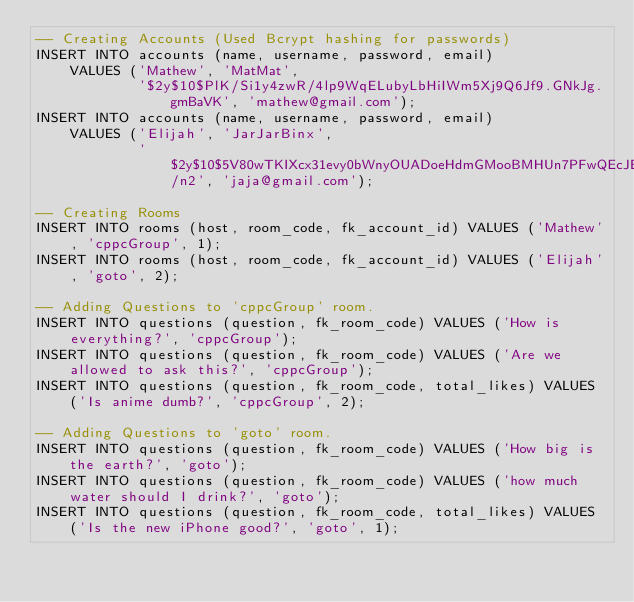Convert code to text. <code><loc_0><loc_0><loc_500><loc_500><_SQL_>-- Creating Accounts (Used Bcrypt hashing for passwords)
INSERT INTO accounts (name, username, password, email)
    VALUES ('Mathew', 'MatMat',
            '$2y$10$PlK/Si1y4zwR/4lp9WqELubyLbHiIWm5Xj9Q6Jf9.GNkJg.gmBaVK', 'mathew@gmail.com');
INSERT INTO accounts (name, username, password, email)
    VALUES ('Elijah', 'JarJarBinx',
            '$2y$10$5V80wTKIXcx31evy0bWnyOUADoeHdmGMooBMHUn7PFwQEcJEg5/n2', 'jaja@gmail.com');

-- Creating Rooms
INSERT INTO rooms (host, room_code, fk_account_id) VALUES ('Mathew', 'cppcGroup', 1);
INSERT INTO rooms (host, room_code, fk_account_id) VALUES ('Elijah', 'goto', 2);

-- Adding Questions to 'cppcGroup' room.
INSERT INTO questions (question, fk_room_code) VALUES ('How is everything?', 'cppcGroup');
INSERT INTO questions (question, fk_room_code) VALUES ('Are we allowed to ask this?', 'cppcGroup');
INSERT INTO questions (question, fk_room_code, total_likes) VALUES ('Is anime dumb?', 'cppcGroup', 2);

-- Adding Questions to 'goto' room.
INSERT INTO questions (question, fk_room_code) VALUES ('How big is the earth?', 'goto');
INSERT INTO questions (question, fk_room_code) VALUES ('how much water should I drink?', 'goto');
INSERT INTO questions (question, fk_room_code, total_likes) VALUES ('Is the new iPhone good?', 'goto', 1);
</code> 